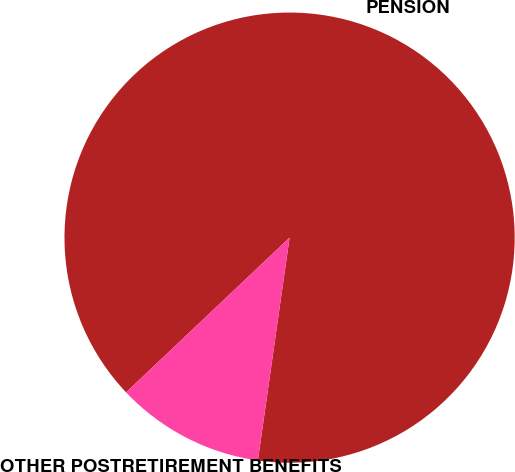Convert chart. <chart><loc_0><loc_0><loc_500><loc_500><pie_chart><fcel>PENSION<fcel>OTHER POSTRETIREMENT BENEFITS<nl><fcel>89.31%<fcel>10.69%<nl></chart> 